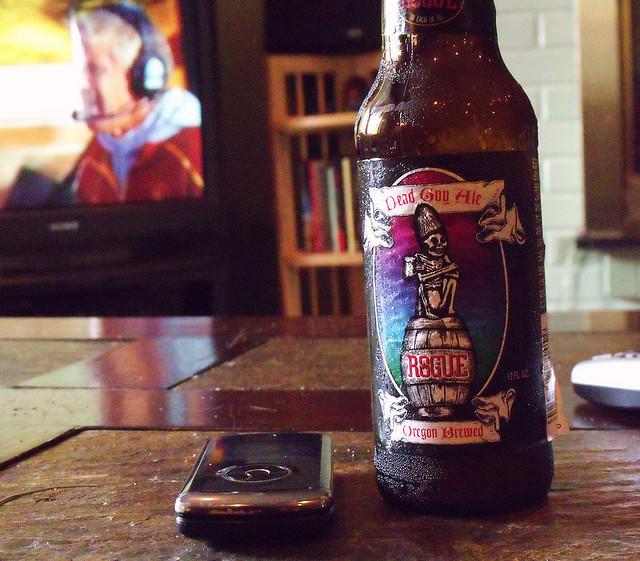Is this a cup?
Short answer required. No. Is that a football game on the TV?
Keep it brief. Yes. What company makes this beer?
Be succinct. Rogue. What brand of beer is this?
Give a very brief answer. Dead guy ale. 